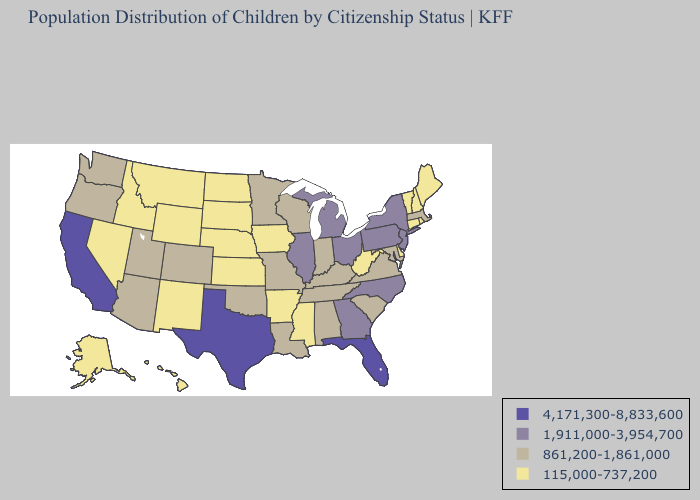Name the states that have a value in the range 1,911,000-3,954,700?
Short answer required. Georgia, Illinois, Michigan, New Jersey, New York, North Carolina, Ohio, Pennsylvania. What is the highest value in the South ?
Quick response, please. 4,171,300-8,833,600. Is the legend a continuous bar?
Quick response, please. No. What is the lowest value in states that border Kentucky?
Concise answer only. 115,000-737,200. Does Michigan have the highest value in the MidWest?
Answer briefly. Yes. What is the highest value in the West ?
Give a very brief answer. 4,171,300-8,833,600. Which states have the highest value in the USA?
Give a very brief answer. California, Florida, Texas. Name the states that have a value in the range 4,171,300-8,833,600?
Give a very brief answer. California, Florida, Texas. Among the states that border Texas , does New Mexico have the highest value?
Give a very brief answer. No. Does Louisiana have the lowest value in the USA?
Short answer required. No. Does the first symbol in the legend represent the smallest category?
Keep it brief. No. Among the states that border New Hampshire , does Vermont have the highest value?
Short answer required. No. What is the value of Nevada?
Quick response, please. 115,000-737,200. Name the states that have a value in the range 115,000-737,200?
Keep it brief. Alaska, Arkansas, Connecticut, Delaware, Hawaii, Idaho, Iowa, Kansas, Maine, Mississippi, Montana, Nebraska, Nevada, New Hampshire, New Mexico, North Dakota, Rhode Island, South Dakota, Vermont, West Virginia, Wyoming. Does Iowa have the same value as Kansas?
Concise answer only. Yes. 